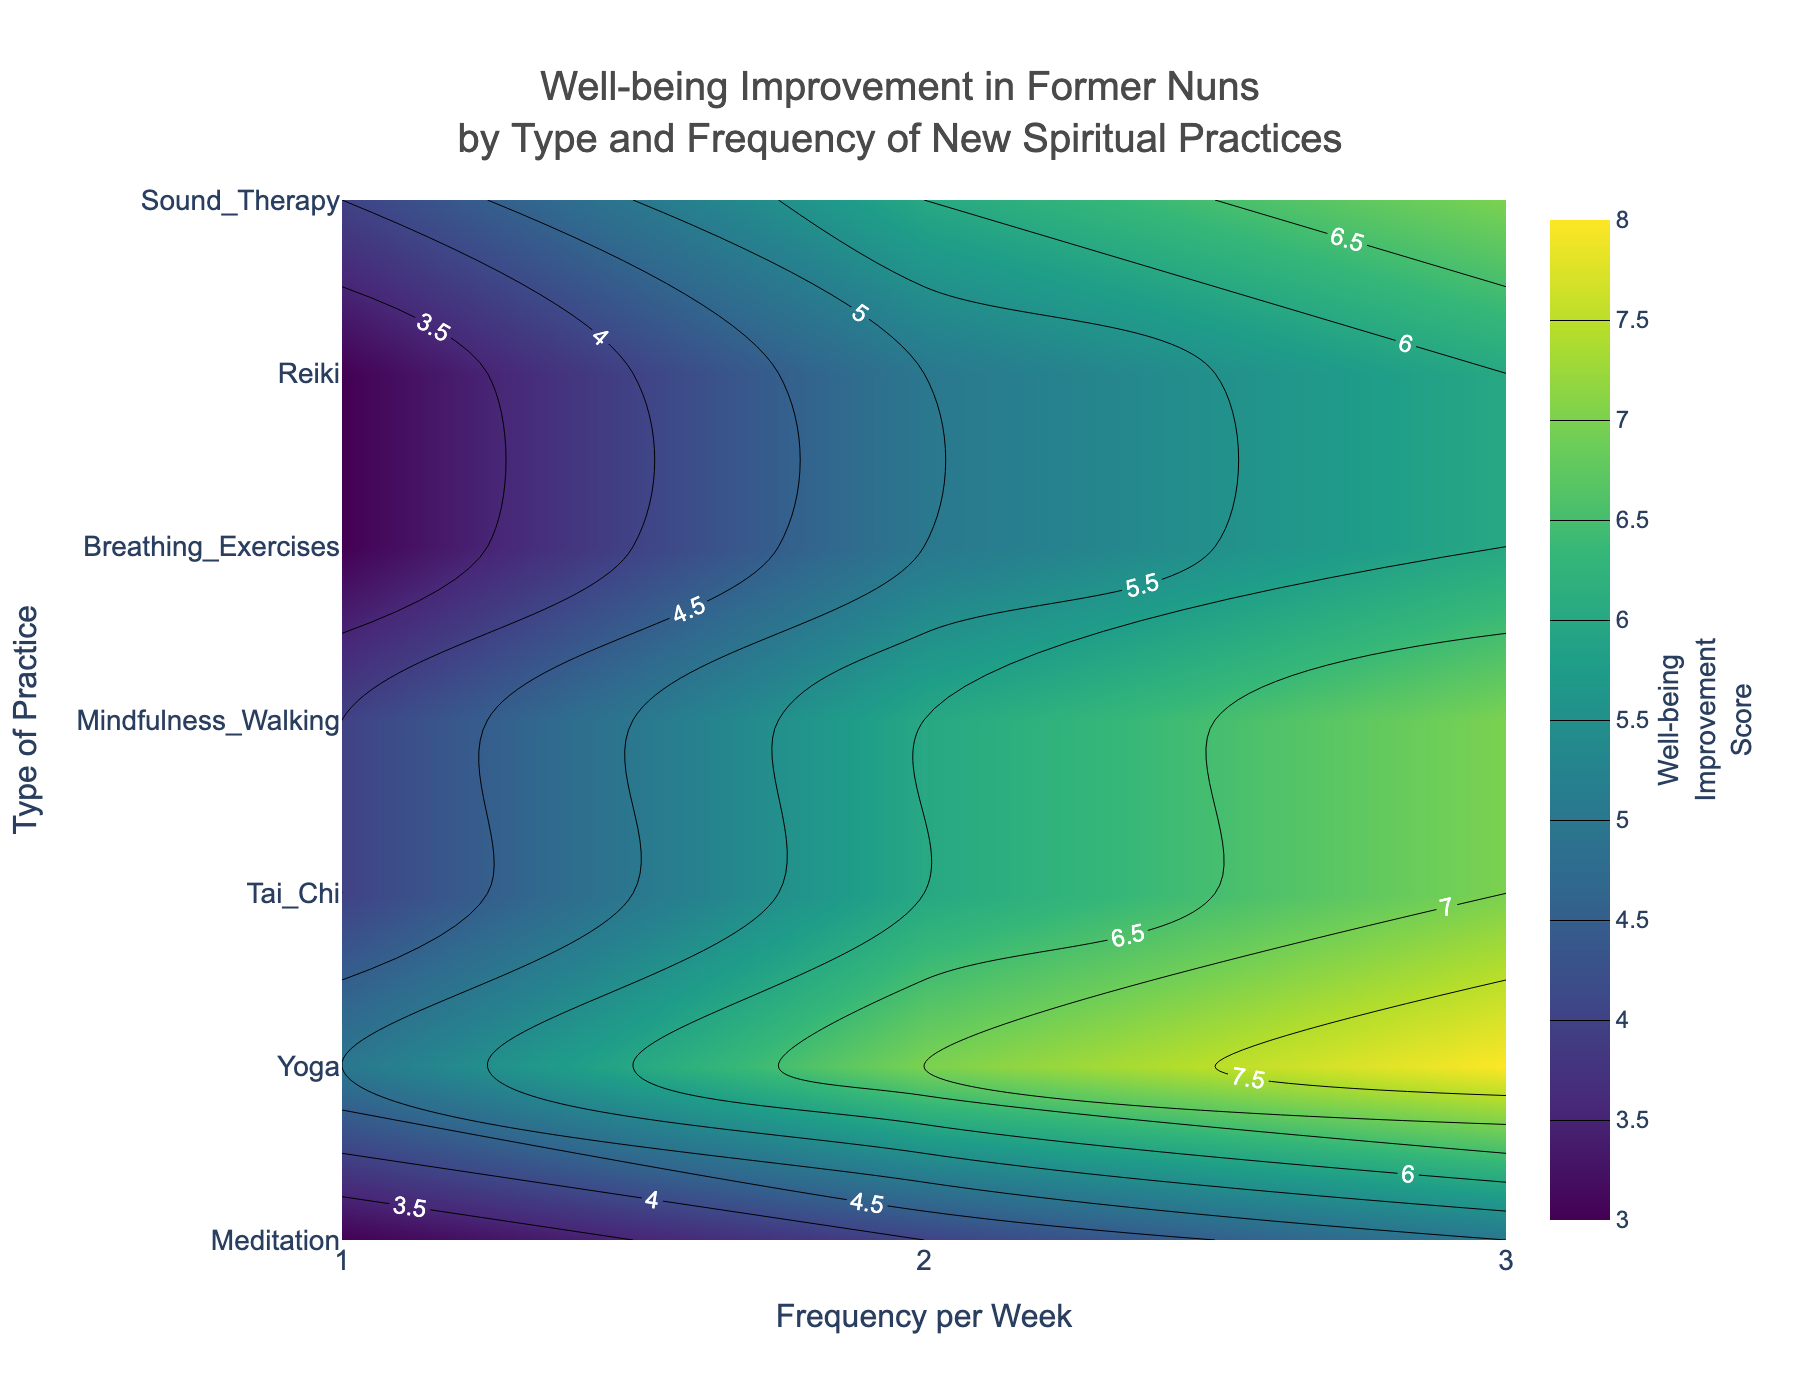What's the title of the plot? The title is always displayed at the top of the plot and it summarizes the main topic being visualized.
Answer: Well-being Improvement in Former Nuns by Type and Frequency of New Spiritual Practices What are the axes labels? The axes labels are usually displayed at the edges of the plot, the x-axis at the bottom and the y-axis at the left side. The labels indicate what is being measured along each axis. In this plot, the x-axis label is 'Frequency per Week' and the y-axis label is 'Type of Practice'.
Answer: Frequency per Week (x-axis), Type of Practice (y-axis) Which spiritual practice has the highest improvement score at 3 times per week? By looking at the plot and finding the highest contour value in the column corresponding to 3 times per week, it can be seen from the color intensity and the labels.
Answer: Meditation How does the well-being improvement score for Yoga compare between 1 and 3 times per week? Examine the improvement scores for Yoga at both 1 and 3 times per week on the y-axis and check their corresponding values. Yoga's improvement score increases from 4 at 1 time per week to 7 at 3 times per week.
Answer: 4 at 1 time/week, 7 at 3 times/week What is the range of the well-being improvement scores depicted in the plot? Determine the minimum and maximum scores displayed on the color bar legend usually on the right side of the contour plot. The minimum score is 3 and the maximum is 8.
Answer: 3 to 8 Which two spiritual practices have the same well-being improvement score at 2 times per week, and what is that score? Check the plot for the contour value at 2 times per week and identify the practices that share the same value and color. Both Yoga and Mindfulness Walking have the same score of 6 at this frequency.
Answer: Yoga and Mindfulness Walking, score 6 If a former nun wants the most improvement in well-being by practicing Reiki, how many times per week should she practice it? Find the highest contour value for Reiki across all frequencies and check the corresponding frequency. The highest score for Reiki is 7 at 3 times per week.
Answer: 3 times per week How does the well-being improvement score for Sound Therapy at 2 times per week compare to Breathing Exercises at 2 times per week? Check the contour values for both Sound Therapy and Breathing Exercises at 2 times per week. Sound Therapy has a score of 5, while Breathing Exercises have a score of 4. This shows Sound Therapy has a higher score at the same frequency.
Answer: Sound Therapy is higher What is the average well-being improvement score for the first week of practice across all types of practices? Find the improvement scores for all practices at 1 time per week and calculate the average. The scores for Meditation, Yoga, Tai Chi, Mindfulness Walking, Breathing Exercises, Reiki, and Sound Therapy are 5, 4, 3, 4, 3, 4, and 3 respectively. The average is (5+4+3+4+3+4+3)/7 = 3.71 (rounded to 2 decimal places).
Answer: 3.71 